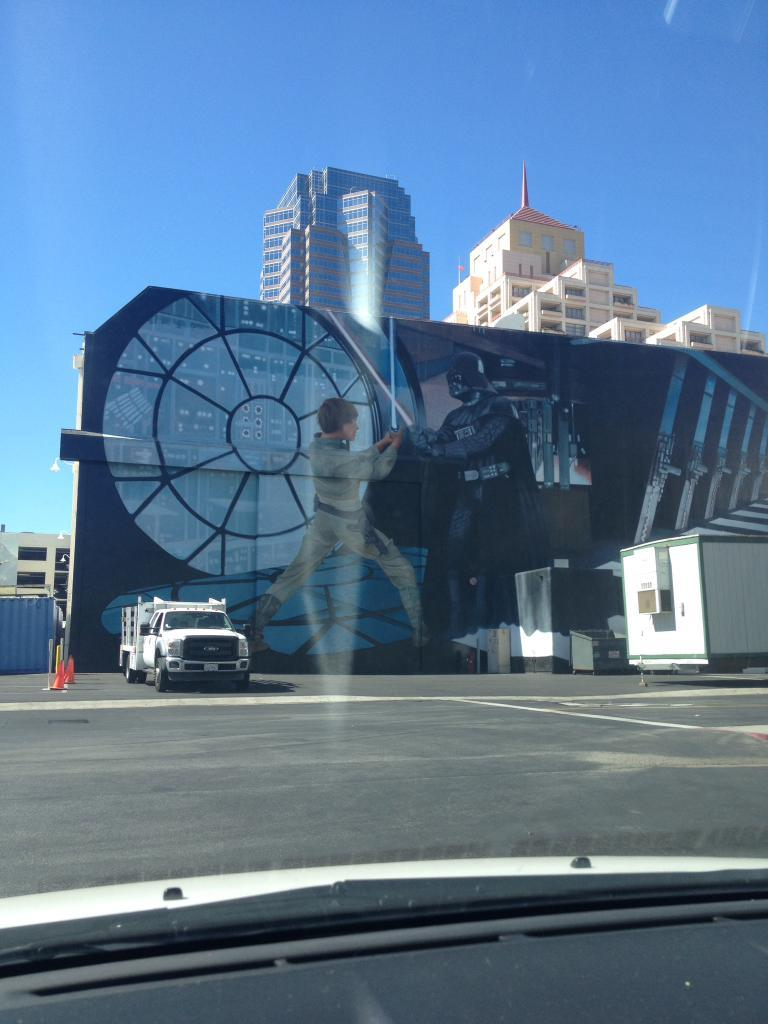What is the main feature of the image? There is a road in the image. What is happening on the road? There are vehicles on the road. What safety measures are visible in the image? Traffic cones are visible in the image. What type of objects are present near the road? Containers are present in the image. What can be seen in the background of the image? There is a wall, buildings, and the sky visible in the background of the image. What type of mouth can be seen on the truck in the image? There is no truck present in the image, and therefore no mouth can be observed on a truck. 